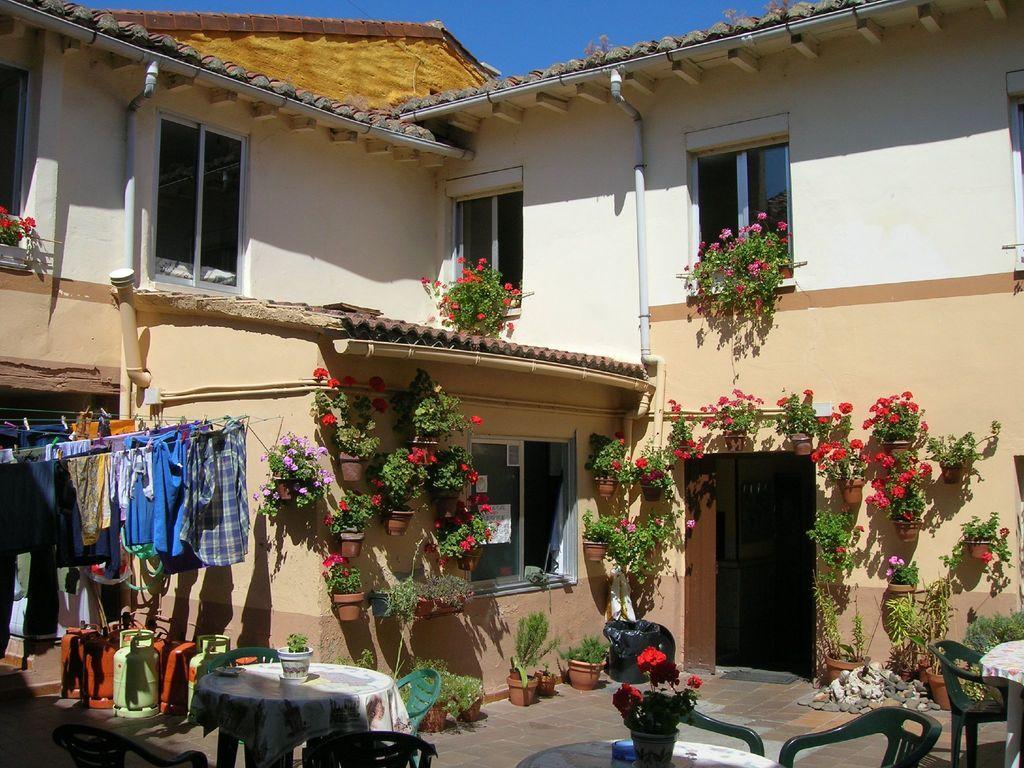Describe this image in one or two sentences. In this image in front there are tables, chairs. On top of the tables there are flower pots. In the background of the image there is a building. There are flower pots. There are glass windows. On the left side of the image there are cylinders. There are clothes hanged to a wire. 